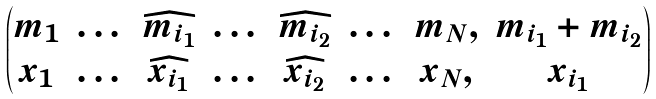<formula> <loc_0><loc_0><loc_500><loc_500>\begin{pmatrix} m _ { 1 } & \dots & \widehat { m _ { i _ { 1 } } } & \dots & \widehat { m _ { i _ { 2 } } } & \dots & m _ { N } , & m _ { i _ { 1 } } + m _ { i _ { 2 } } \\ x _ { 1 } & \dots & \widehat { x _ { i _ { 1 } } } & \dots & \widehat { x _ { i _ { 2 } } } & \dots & x _ { N } , & x _ { i _ { 1 } } \end{pmatrix}</formula> 